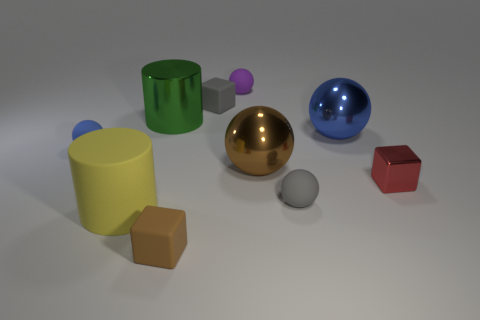What number of other objects are there of the same size as the red cube? Among the objects presented, it appears that the purple sphere is the closest in size to the red cube, and thus there is one object of similar size. 